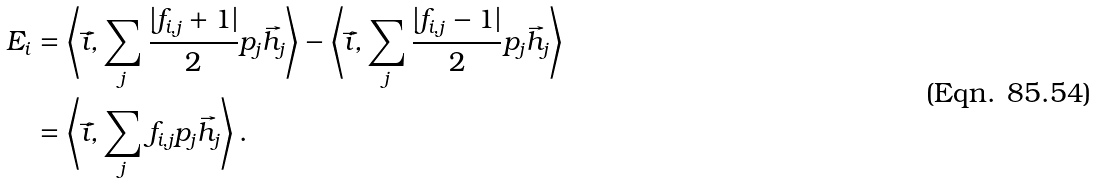Convert formula to latex. <formula><loc_0><loc_0><loc_500><loc_500>E _ { i } & = \left \langle \vec { i } , \sum _ { j } \frac { | f _ { i , j } + 1 | } { 2 } p _ { j } \vec { h } _ { j } \right \rangle - \left \langle \vec { i } , \sum _ { j } \frac { | f _ { i , j } - 1 | } { 2 } p _ { j } \vec { h } _ { j } \right \rangle \\ & = \left \langle \vec { i } , \sum _ { j } f _ { i , j } p _ { j } \vec { h } _ { j } \right \rangle .</formula> 